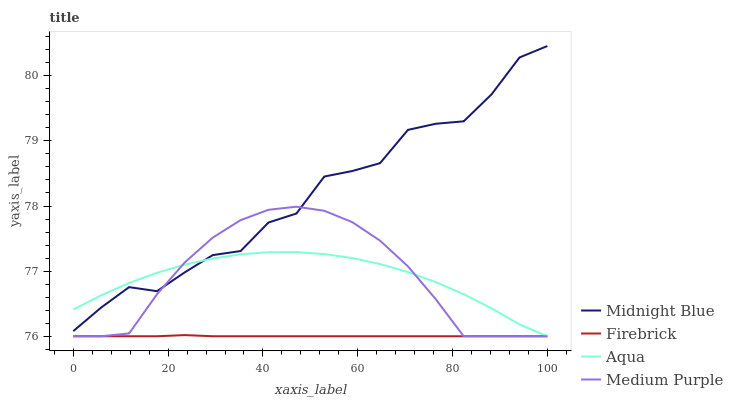Does Firebrick have the minimum area under the curve?
Answer yes or no. Yes. Does Midnight Blue have the maximum area under the curve?
Answer yes or no. Yes. Does Aqua have the minimum area under the curve?
Answer yes or no. No. Does Aqua have the maximum area under the curve?
Answer yes or no. No. Is Firebrick the smoothest?
Answer yes or no. Yes. Is Midnight Blue the roughest?
Answer yes or no. Yes. Is Aqua the smoothest?
Answer yes or no. No. Is Aqua the roughest?
Answer yes or no. No. Does Medium Purple have the lowest value?
Answer yes or no. Yes. Does Midnight Blue have the lowest value?
Answer yes or no. No. Does Midnight Blue have the highest value?
Answer yes or no. Yes. Does Aqua have the highest value?
Answer yes or no. No. Is Firebrick less than Midnight Blue?
Answer yes or no. Yes. Is Midnight Blue greater than Firebrick?
Answer yes or no. Yes. Does Medium Purple intersect Aqua?
Answer yes or no. Yes. Is Medium Purple less than Aqua?
Answer yes or no. No. Is Medium Purple greater than Aqua?
Answer yes or no. No. Does Firebrick intersect Midnight Blue?
Answer yes or no. No. 